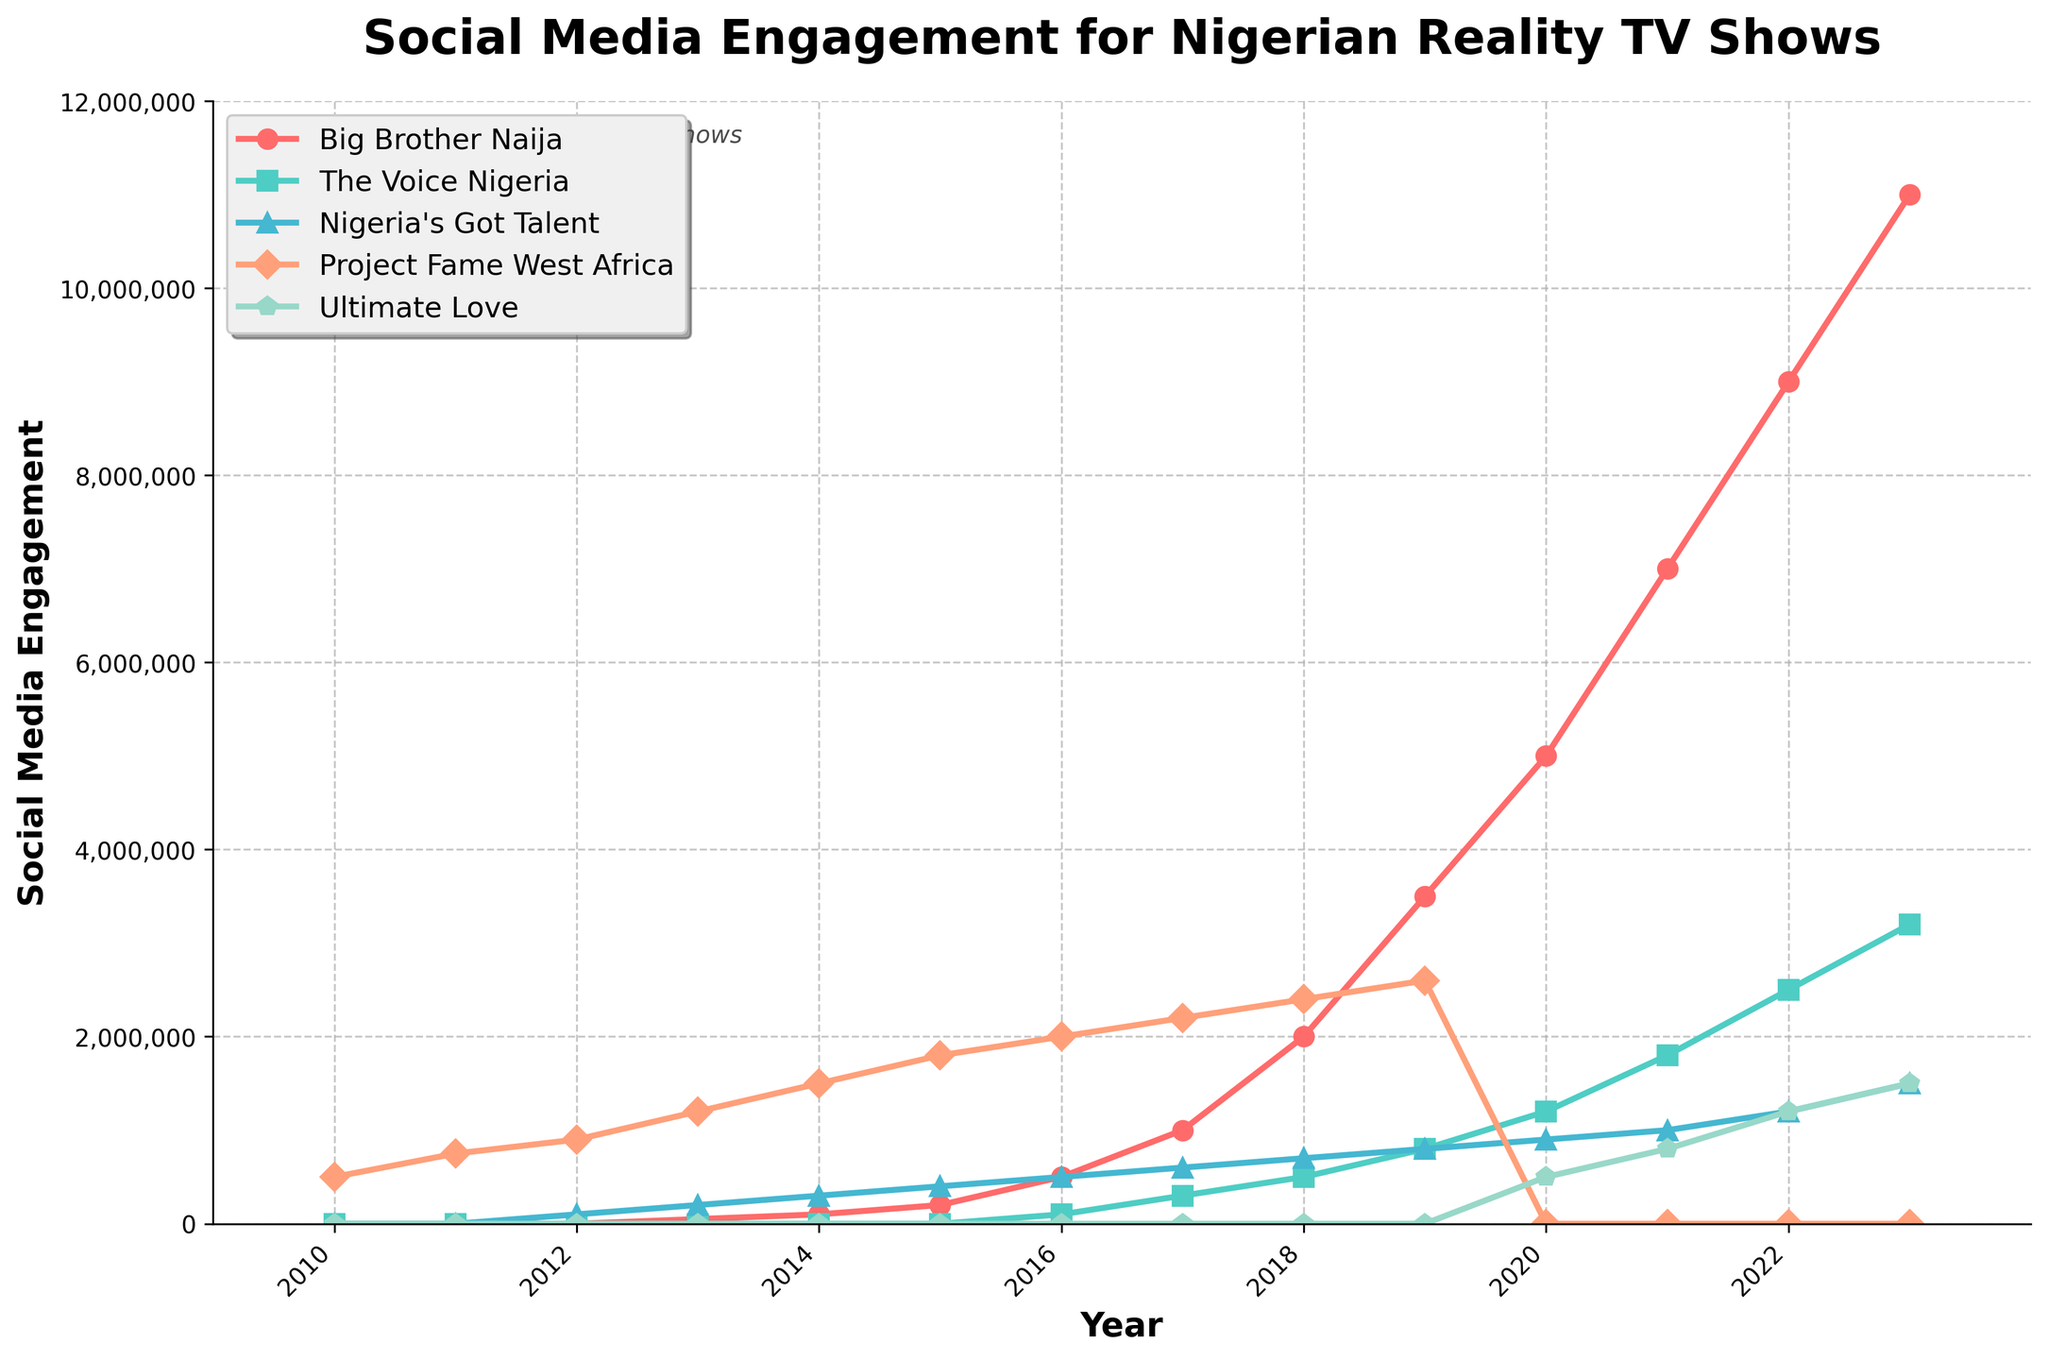Which reality TV show had the highest social media engagement in 2023? In 2023, Big Brother Naija has the highest value on the line chart, at 11,000,000.
Answer: Big Brother Naija How did the social media engagement for The Voice Nigeria change from 2016 to 2023? In 2016, The Voice Nigeria had an engagement of 100,000, and it increased each year, reaching 3,200,000 by 2023.
Answer: It increased significantly from 100,000 to 3,200,000 Between Project Fame West Africa and Nigeria's Got Talent, which show had more consistent growth from 2010 to 2023? Project Fame West Africa showed consistent growth until 2019 and then dropped to 0 in 2020, while Nigeria's Got Talent shows a more erratic growth pattern.
Answer: Project Fame West Africa What is the total social media engagement for Ultimate Love in 2022 and 2023 combined? The engagement for Ultimate Love in 2022 is 1,200,000 and in 2023 is 1,500,000. Adding these together gives 1,200,000 + 1,500,000.
Answer: 2,700,000 Which show saw a decrease in social media engagement between any two consecutive years? Project Fame West Africa saw a decrease between 2019 and 2020, dropping from 2,600,000 to 0.
Answer: Project Fame West Africa In which year did Big Brother Naija surpass social media engagement of 1,000,000? From the chart, Big Brother Naija surpassed 1,000,000 social media engagements in 2017, when it reached 1,000,000.
Answer: 2017 What is the difference in social media engagements between Big Brother Naija and The Voice Nigeria in 2023? In 2023, Big Brother Naija had 11,000,000 engagements while The Voice Nigeria had 3,200,000. The difference is 11,000,000 - 3,200,000.
Answer: 7,800,000 Which reality TV show had no social media engagement in 2020? According to the chart, Project Fame West Africa had no social media engagement in 2020.
Answer: Project Fame West Africa How much did Nigeria's Got Talent's social media engagement increase from 2010 to 2023? In 2010, Nigeria's Got Talent had 0 engagements. By 2023, this had increased to 1,500,000. Therefore, the increase is 1,500,000 - 0.
Answer: 1,500,000 